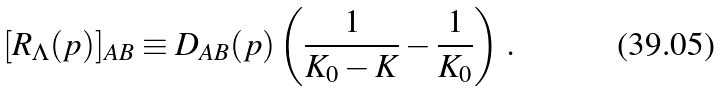Convert formula to latex. <formula><loc_0><loc_0><loc_500><loc_500>[ R _ { \Lambda } ( p ) ] _ { A B } \equiv D _ { A B } ( p ) \left ( \frac { 1 } { K _ { 0 } - K } - \frac { 1 } { K _ { 0 } } \right ) \, .</formula> 